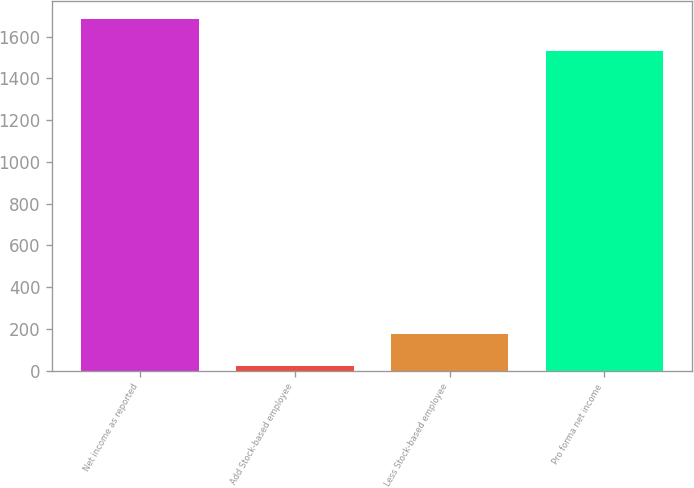Convert chart. <chart><loc_0><loc_0><loc_500><loc_500><bar_chart><fcel>Net income as reported<fcel>Add Stock-based employee<fcel>Less Stock-based employee<fcel>Pro forma net income<nl><fcel>1686.66<fcel>20.7<fcel>175.46<fcel>1531.9<nl></chart> 